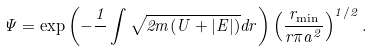Convert formula to latex. <formula><loc_0><loc_0><loc_500><loc_500>\Psi = \exp \left ( - \frac { 1 } { } \int \sqrt { 2 m ( U + | E | ) } d r \right ) \left ( \frac { r _ { \min } } { r \pi a ^ { 2 } } \right ) ^ { 1 / 2 } .</formula> 